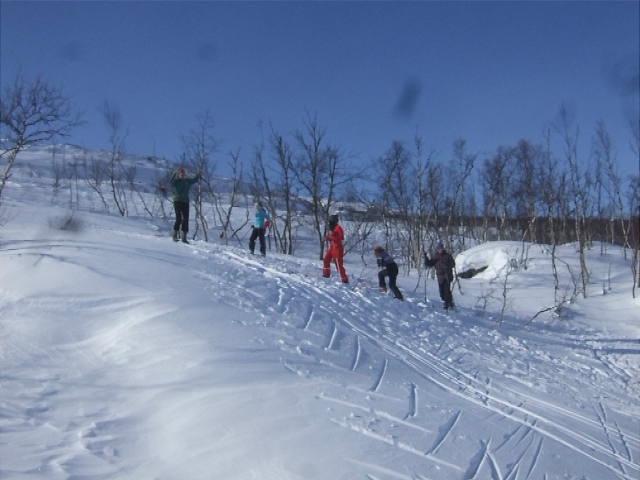How many people are wearing red?
Answer briefly. 1. How many people are in the picture?
Short answer required. 5. What are these people doing?
Write a very short answer. Skiing. 